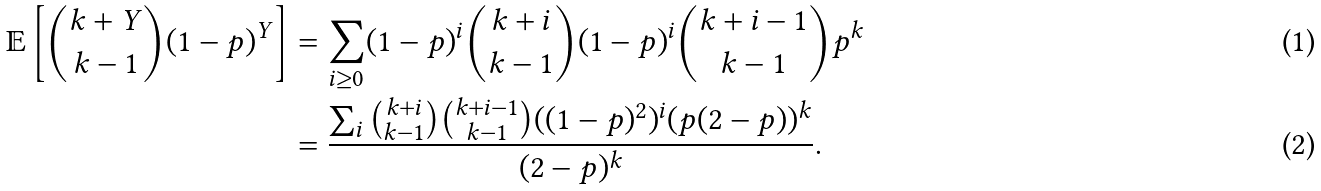Convert formula to latex. <formula><loc_0><loc_0><loc_500><loc_500>\mathbb { E } \left [ \binom { k + Y } { k - 1 } ( 1 - p ) ^ { Y } \right ] & = \sum _ { i \geq 0 } ( 1 - p ) ^ { i } \binom { k + i } { k - 1 } ( 1 - p ) ^ { i } \binom { k + i - 1 } { k - 1 } p ^ { k } \\ & = \frac { \sum _ { i } \binom { k + i } { k - 1 } \binom { k + i - 1 } { k - 1 } ( ( 1 - p ) ^ { 2 } ) ^ { i } ( p ( 2 - p ) ) ^ { k } } { ( 2 - p ) ^ { k } } .</formula> 